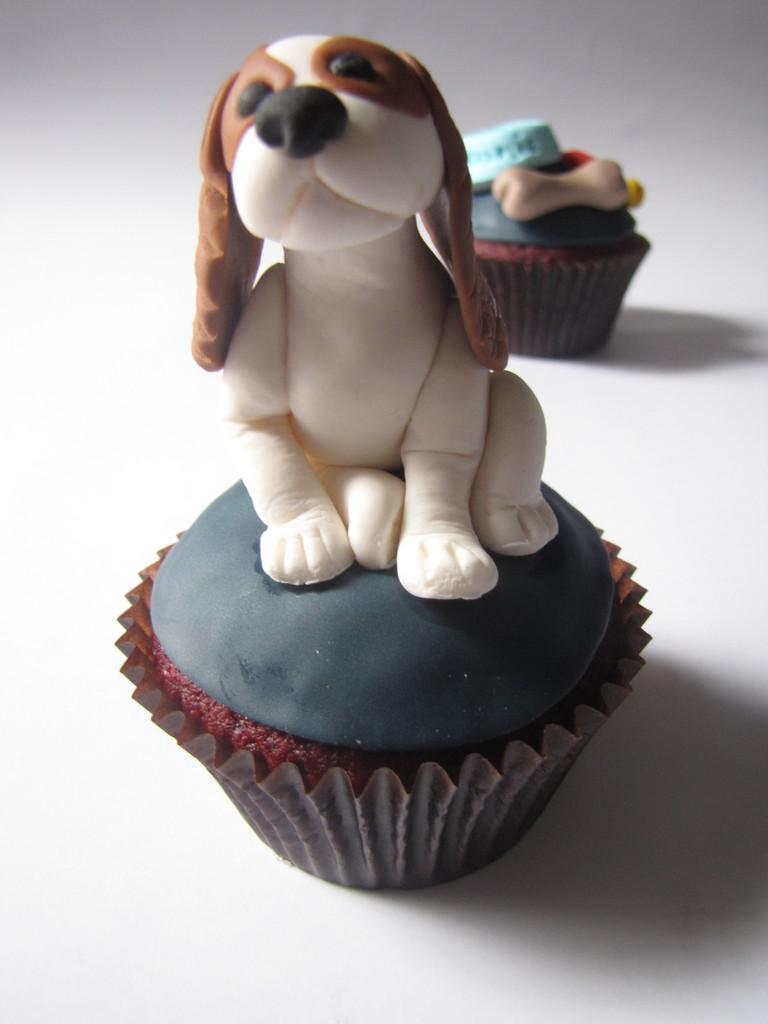Please provide a concise description of this image. In this image we can see cupcakes. 